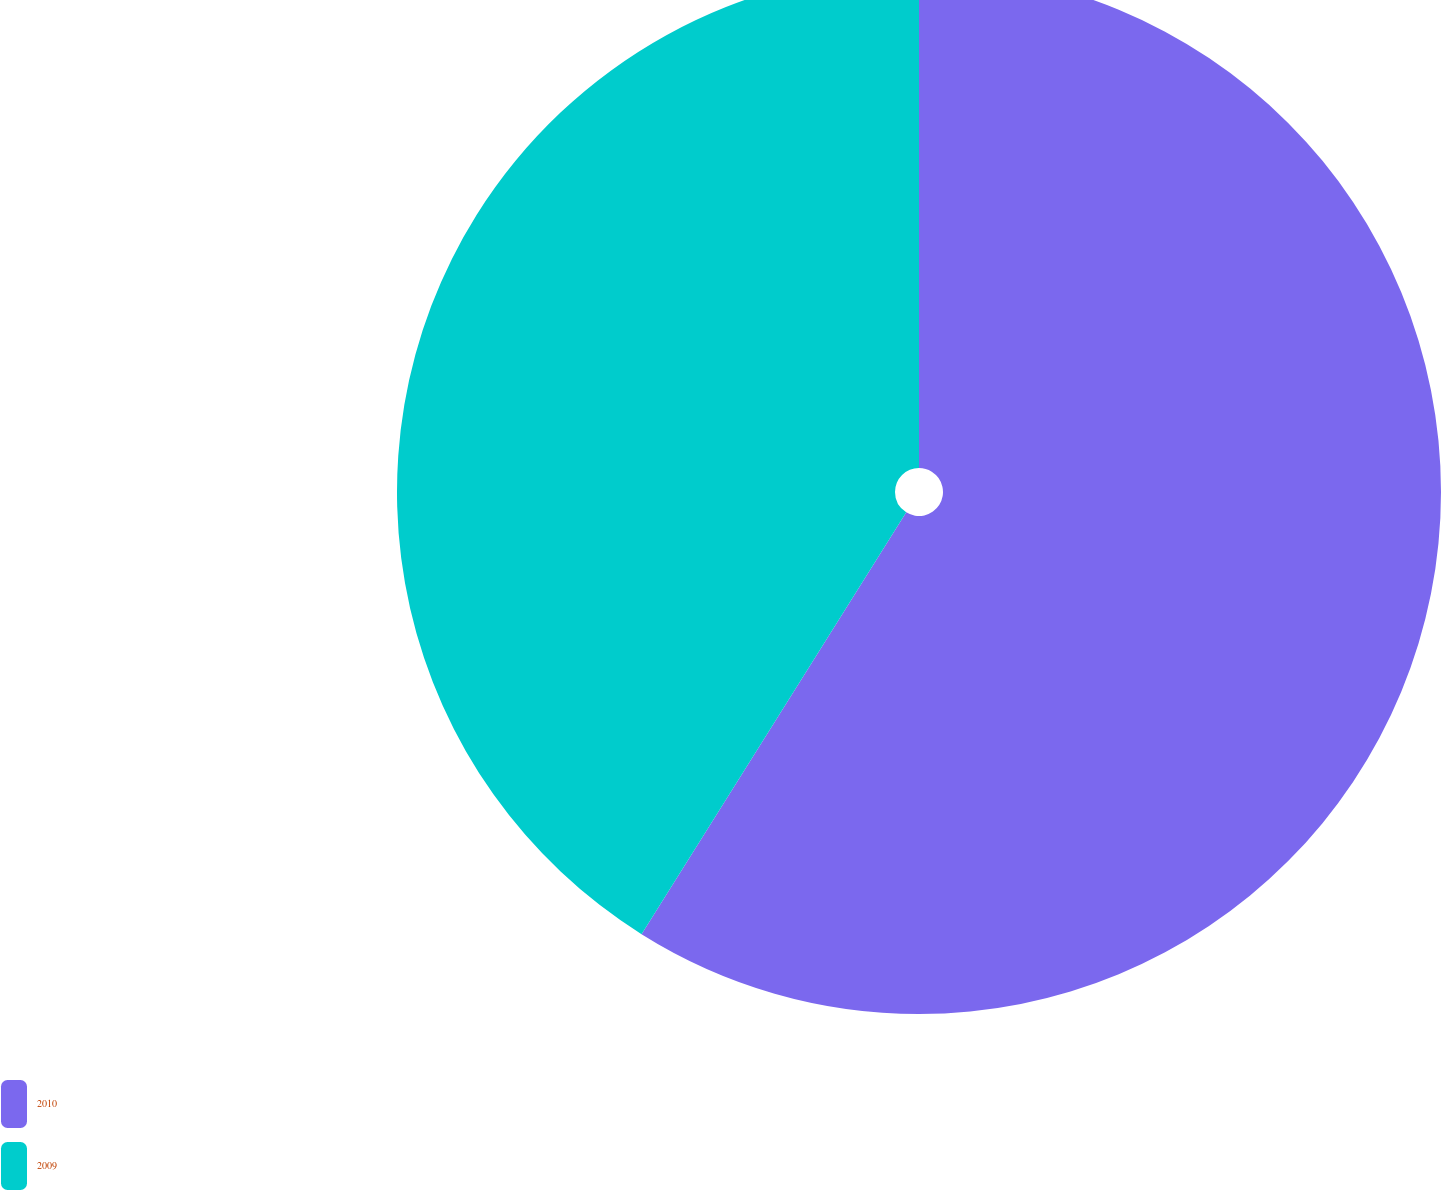<chart> <loc_0><loc_0><loc_500><loc_500><pie_chart><fcel>2010<fcel>2009<nl><fcel>58.92%<fcel>41.08%<nl></chart> 